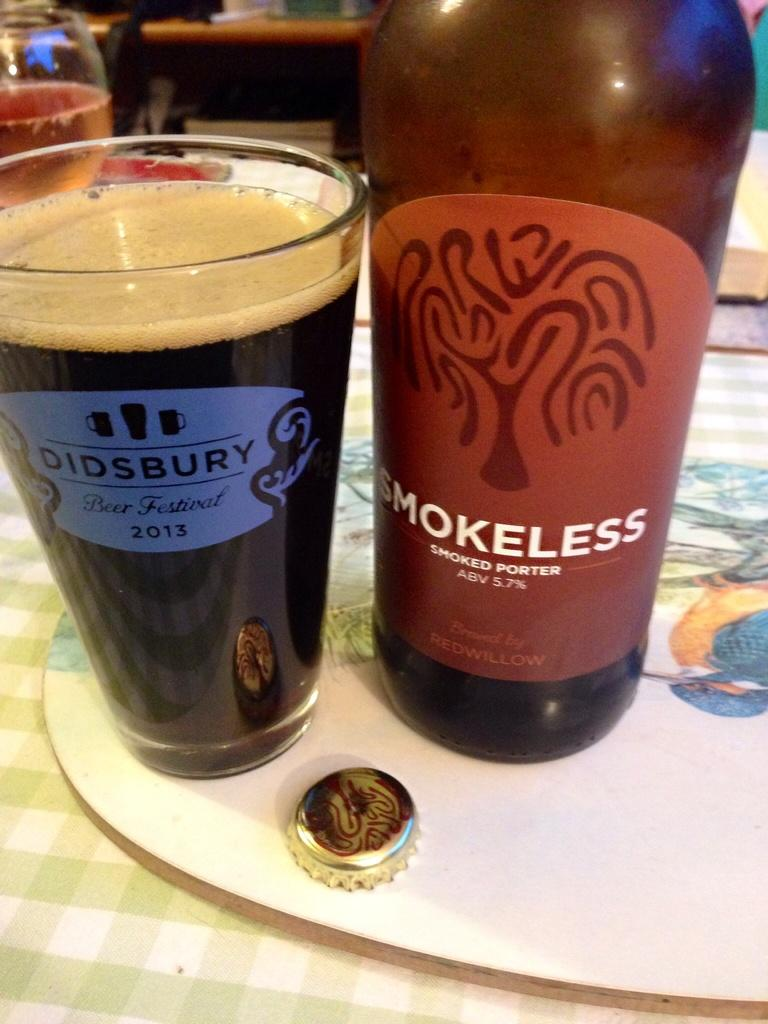<image>
Present a compact description of the photo's key features. A bottle of Smokeless Smoked Porter is poured into a glass next to it. 